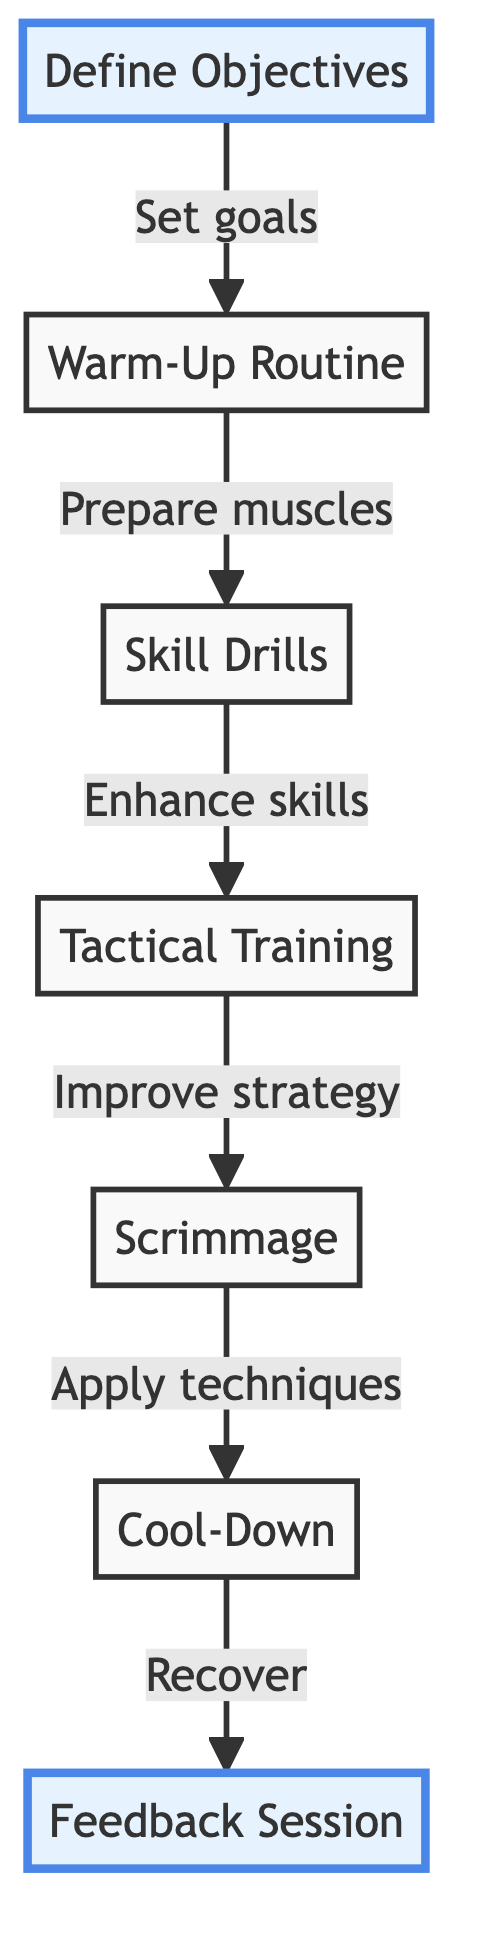What is the first step in the training session? The first step is "Define Objectives," which sets the specific goals for the training session.
Answer: Define Objectives How many main steps are there in the training session? There are six main steps in the flowchart, from "Define Objectives" to "Feedback Session."
Answer: 6 What comes after "Warm-Up Routine"? After "Warm-Up Routine," the next step is "Skill Drills," which is designed to enhance individual skills.
Answer: Skill Drills What is the purpose of the "Feedback Session"? The purpose of the "Feedback Session" is to hold a brief meeting to discuss positives and areas for improvement from the session.
Answer: Discuss positives and areas for improvement Which two steps focus on improving technique and strategy? The steps focusing on improvement are "Tactical Training" and "Scrimmage," as they involve practicing strategy and applying techniques in a game setting.
Answer: Tactical Training and Scrimmage Explain the relationship between "Scrimmage" and "Cool-Down." The relationship is that "Scrimmage" is a controlled practice game where techniques are applied, which is then followed by "Cool-Down," allowing athletes' muscles to recover after exertion.
Answer: Scrimmage applies techniques; Cool-Down helps recovery What are the actions during the "Warm-Up Routine"? The actions during "Warm-Up Routine" include dynamic stretches and light jogging to prepare the athletes' muscles for more intense activity.
Answer: Dynamic stretches and light jogging What is the focus of "Tactical Training"? The focus of "Tactical Training" is to implement scenario-based exercises to improve team coordination and strategy, such as practicing set-pieces.
Answer: Improve team coordination and strategy Which steps are highlighted in the diagram? The highlighted steps in the diagram are "Define Objectives" and "Feedback Session," indicating their importance in the flow of the training session.
Answer: Define Objectives and Feedback Session 